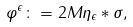Convert formula to latex. <formula><loc_0><loc_0><loc_500><loc_500>\varphi ^ { \epsilon } \colon = 2 M \eta _ { \epsilon } * \sigma ,</formula> 